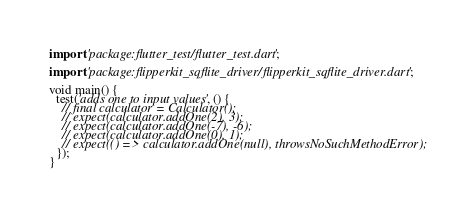<code> <loc_0><loc_0><loc_500><loc_500><_Dart_>import 'package:flutter_test/flutter_test.dart';

import 'package:flipperkit_sqflite_driver/flipperkit_sqflite_driver.dart';

void main() {
  test('adds one to input values', () {
    // final calculator = Calculator();
    // expect(calculator.addOne(2), 3);
    // expect(calculator.addOne(-7), -6);
    // expect(calculator.addOne(0), 1);
    // expect(() => calculator.addOne(null), throwsNoSuchMethodError);
  });
}
</code> 